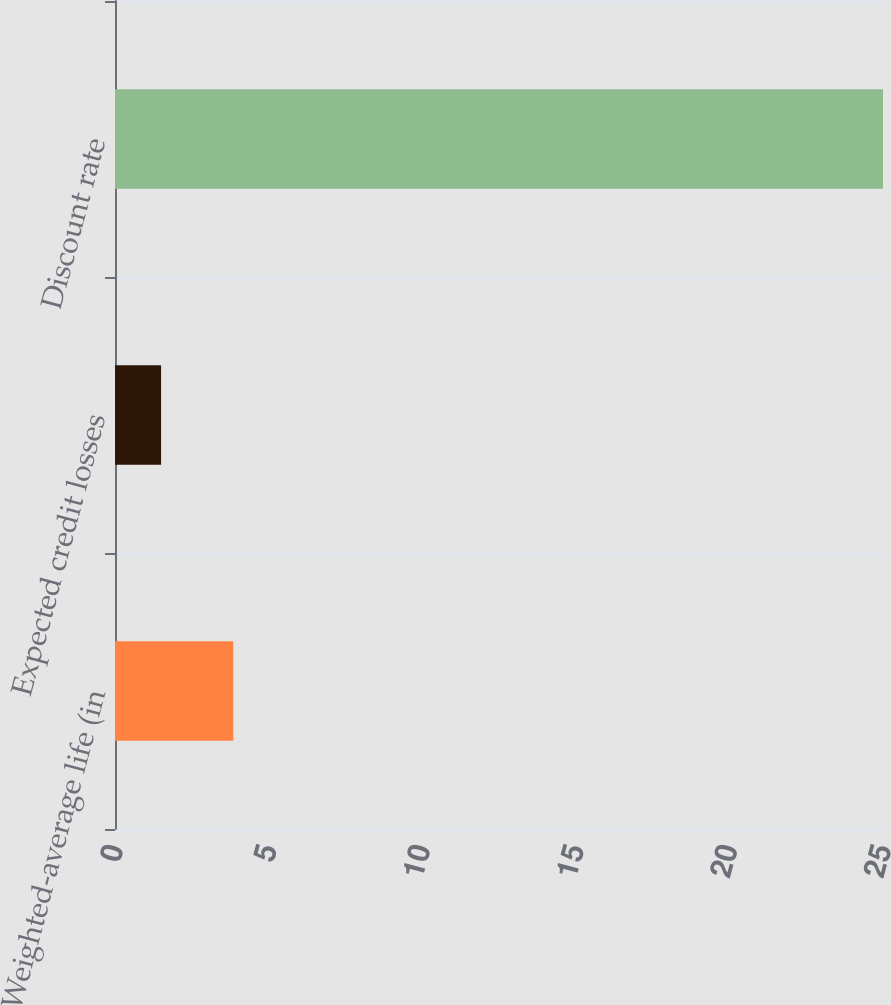Convert chart. <chart><loc_0><loc_0><loc_500><loc_500><bar_chart><fcel>Weighted-average life (in<fcel>Expected credit losses<fcel>Discount rate<nl><fcel>3.85<fcel>1.5<fcel>25<nl></chart> 